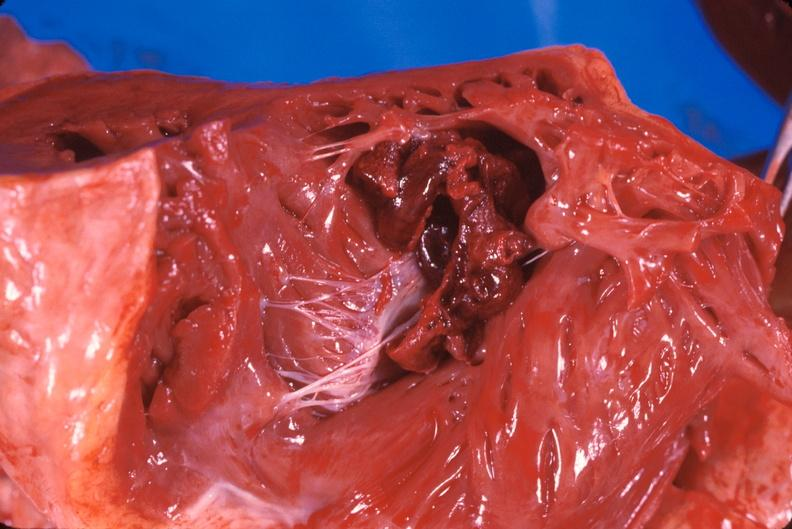s cranial artery present?
Answer the question using a single word or phrase. No 